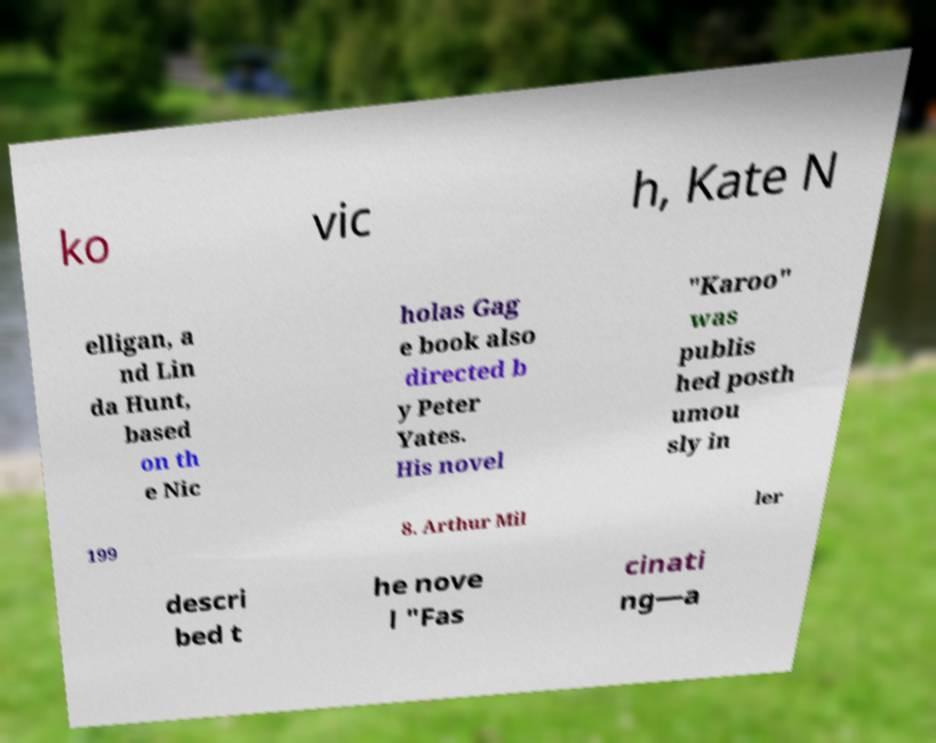Could you assist in decoding the text presented in this image and type it out clearly? ko vic h, Kate N elligan, a nd Lin da Hunt, based on th e Nic holas Gag e book also directed b y Peter Yates. His novel "Karoo" was publis hed posth umou sly in 199 8. Arthur Mil ler descri bed t he nove l "Fas cinati ng—a 